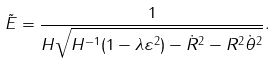<formula> <loc_0><loc_0><loc_500><loc_500>\tilde { E } = \frac { 1 } { H \sqrt { H ^ { - 1 } ( 1 - \lambda \varepsilon ^ { 2 } ) - \dot { R } ^ { 2 } - R ^ { 2 } \dot { \theta } ^ { 2 } } } .</formula> 